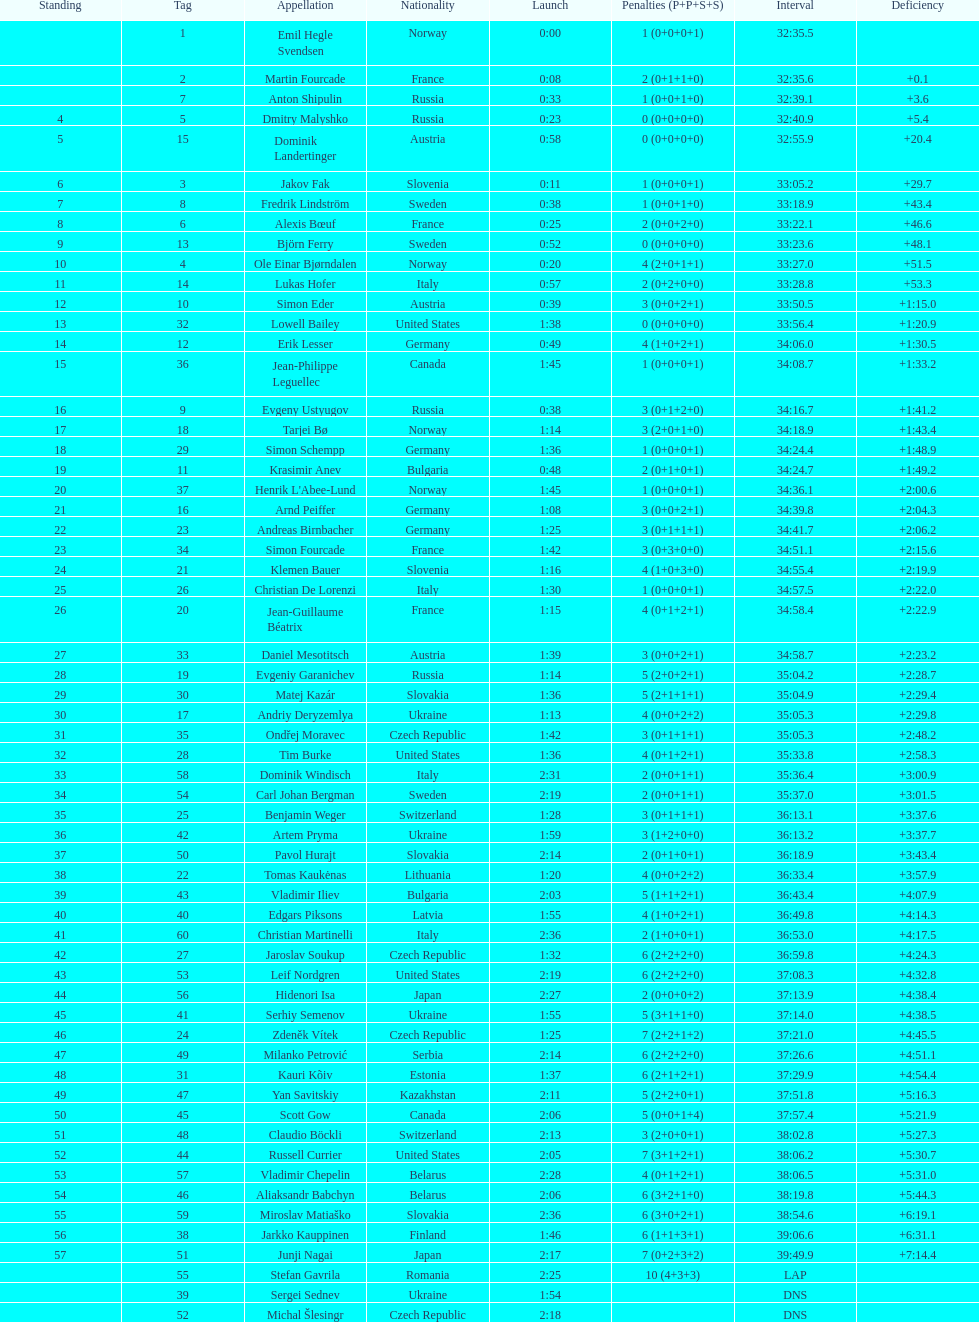What is the number of russian participants? 4. 